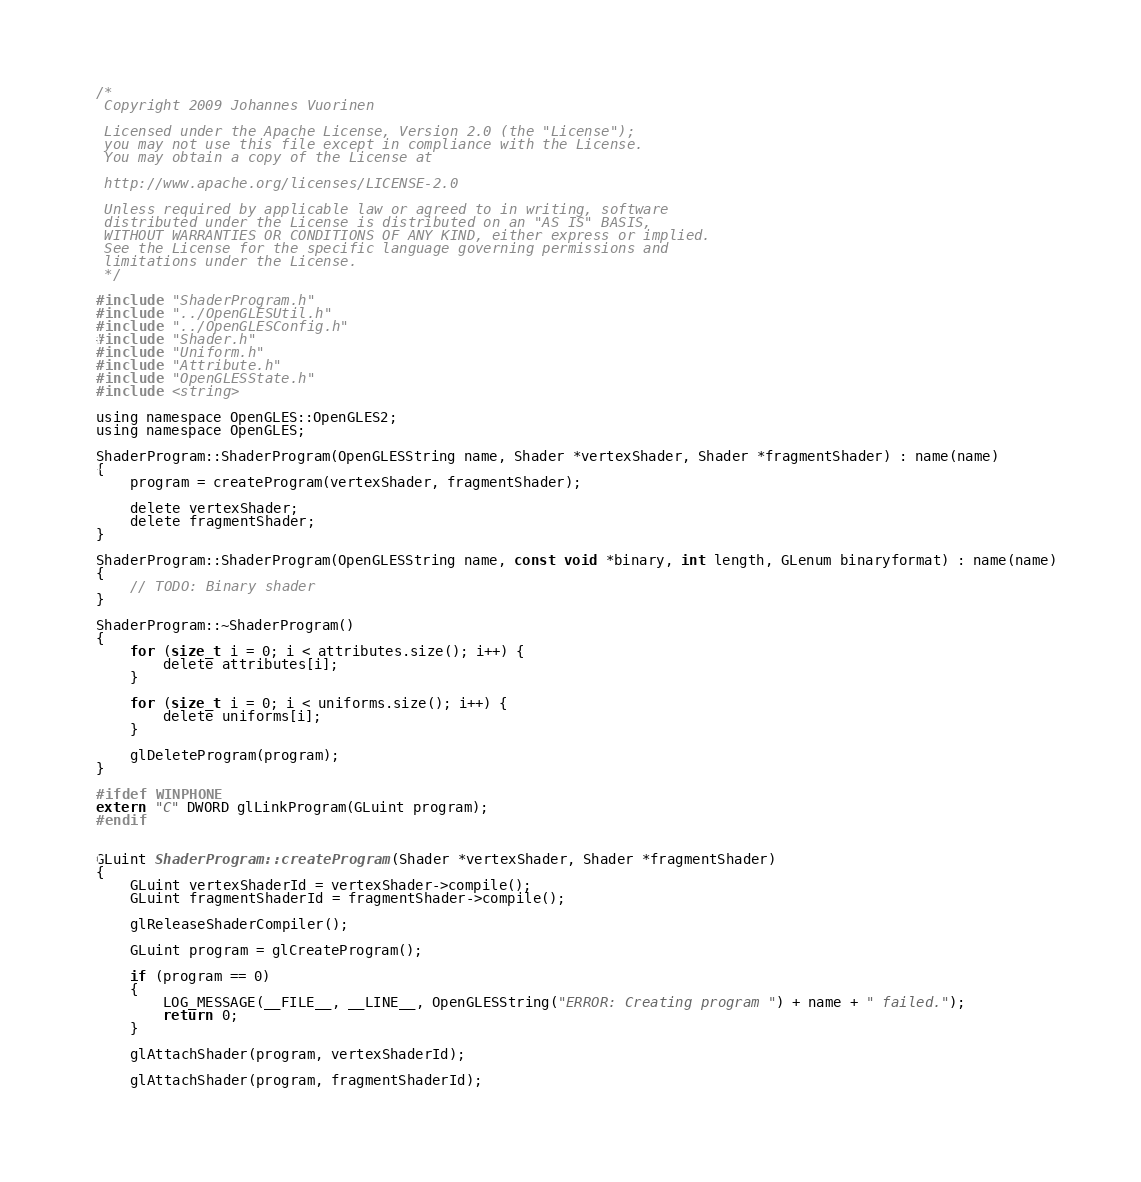Convert code to text. <code><loc_0><loc_0><loc_500><loc_500><_ObjectiveC_>/*
 Copyright 2009 Johannes Vuorinen
 
 Licensed under the Apache License, Version 2.0 (the "License");
 you may not use this file except in compliance with the License.
 You may obtain a copy of the License at 
 
 http://www.apache.org/licenses/LICENSE-2.0 
 
 Unless required by applicable law or agreed to in writing, software
 distributed under the License is distributed on an "AS IS" BASIS,
 WITHOUT WARRANTIES OR CONDITIONS OF ANY KIND, either express or implied.
 See the License for the specific language governing permissions and
 limitations under the License.
 */

#include "ShaderProgram.h"
#include "../OpenGLESUtil.h"
#include "../OpenGLESConfig.h"
#include "Shader.h"
#include "Uniform.h"
#include "Attribute.h"
#include "OpenGLESState.h"
#include <string>

using namespace OpenGLES::OpenGLES2;
using namespace OpenGLES;

ShaderProgram::ShaderProgram(OpenGLESString name, Shader *vertexShader, Shader *fragmentShader) : name(name)
{
    program = createProgram(vertexShader, fragmentShader);
    
    delete vertexShader;
    delete fragmentShader;
}

ShaderProgram::ShaderProgram(OpenGLESString name, const void *binary, int length, GLenum binaryformat) : name(name)
{
    // TODO: Binary shader
}

ShaderProgram::~ShaderProgram() 
{   
    for (size_t i = 0; i < attributes.size(); i++) {
        delete attributes[i];
    }
    
    for (size_t i = 0; i < uniforms.size(); i++) {
        delete uniforms[i];
    }
    
    glDeleteProgram(program);
}

#ifdef WINPHONE
extern "C" DWORD glLinkProgram(GLuint program);
#endif


GLuint ShaderProgram::createProgram(Shader *vertexShader, Shader *fragmentShader) 
{
    GLuint vertexShaderId = vertexShader->compile();
    GLuint fragmentShaderId = fragmentShader->compile();
    
    glReleaseShaderCompiler();
    
    GLuint program = glCreateProgram();
    
    if (program == 0) 
    {
        LOG_MESSAGE(__FILE__, __LINE__, OpenGLESString("ERROR: Creating program ") + name + " failed.");
        return 0;
    }
    
    glAttachShader(program, vertexShaderId);
    
    glAttachShader(program, fragmentShaderId);
    </code> 